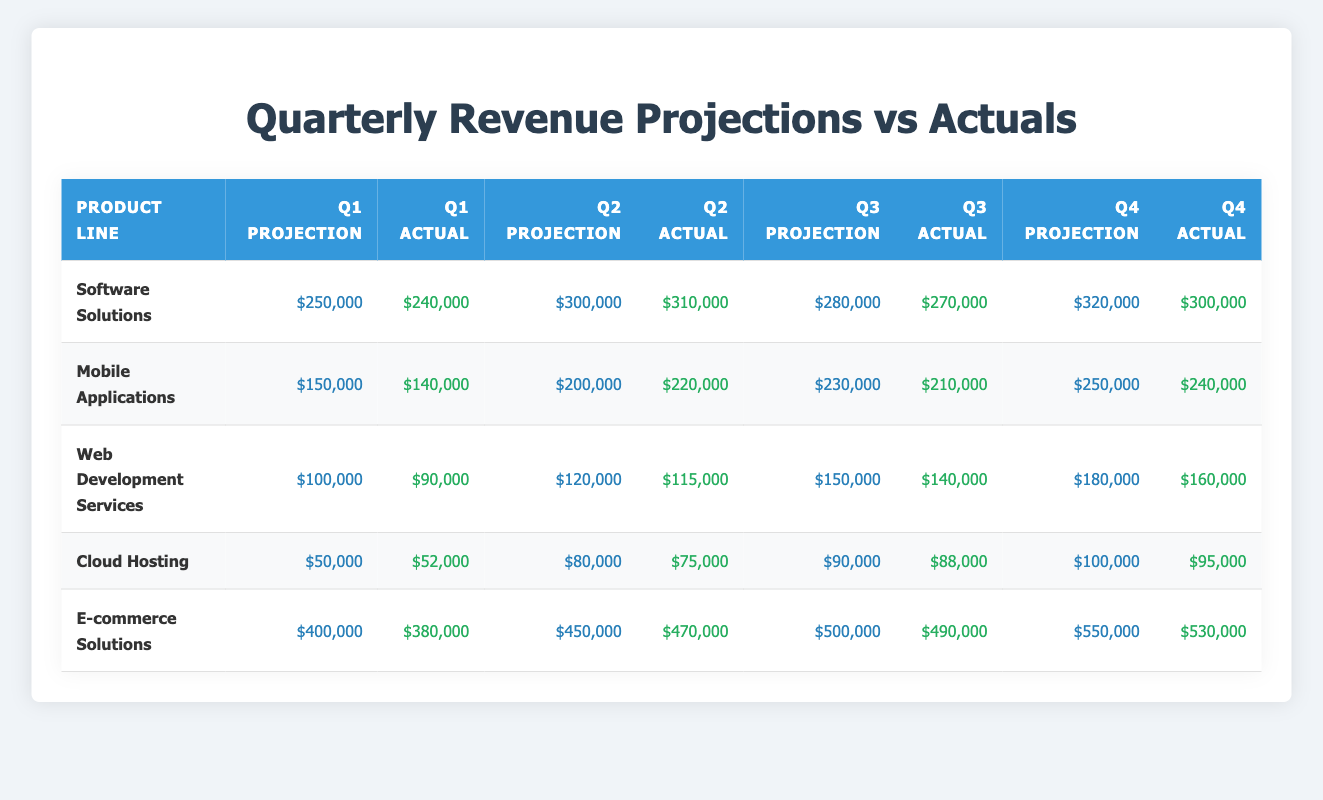What is the projected revenue for the Software Solutions product line in Q3? The table shows that the projection for the Software Solutions product line in Q3 is $280,000.
Answer: $280,000 What is the actual revenue for Mobile Applications in Q2? According to the table, the actual revenue for Mobile Applications in Q2 is $220,000.
Answer: $220,000 Is the actual revenue for Cloud Hosting in Q1 higher than its projection? The actual revenue for Cloud Hosting in Q1 is $52,000, while the projection was $50,000, so yes, it is higher.
Answer: Yes What was the total projected revenue for all product lines in Q4? The total projected revenue in Q4 is calculated by summing the projections: $320,000 (Software Solutions) + $250,000 (Mobile Applications) + $180,000 (Web Development Services) + $100,000 (Cloud Hosting) + $550,000 (E-commerce Solutions) = $1,400,000.
Answer: $1,400,000 What is the difference between Q3 actuals and projections for Web Development Services? The actual revenue for Q3 of Web Development Services is $140,000, and the projection is $150,000. The difference is $150,000 - $140,000 = $10,000.
Answer: $10,000 For which product line was the average of actual revenues (across all quarters) the highest? To find this, we calculate the average of actual revenues for each product: Software Solutions: (240,000 + 310,000 + 270,000 + 300,000) / 4 = 280,000; Mobile Applications: (140,000 + 220,000 + 210,000 + 240,000) / 4 = 202,500; Web Development Services: (90,000 + 115,000 + 140,000 + 160,000) / 4 = 126,250; Cloud Hosting: (52,000 + 75,000 + 88,000 + 95,000) / 4 = 77,500; E-commerce Solutions: (380,000 + 470,000 + 490,000 + 530,000) / 4 = 467,500. The highest average is for E-commerce Solutions.
Answer: E-commerce Solutions Which product line had the largest discrepancy between projection and actual revenue in Q2? For Q2, the discrepancies are as follows: Software Solutions: 300,000 - 310,000 = 10,000; Mobile Applications: 200,000 - 220,000 = 20,000; Web Development Services: 120,000 - 115,000 = 5,000; Cloud Hosting: 80,000 - 75,000 = 5,000; E-commerce Solutions: 450,000 - 470,000 = 20,000. The largest discrepancy is for Mobile Applications & E-commerce Solutions with $20,000.
Answer: Mobile Applications & E-commerce Solutions What is the total actual revenue for all product lines in Q1? The total actual revenue in Q1 is calculated by summing the actual revenues: $240,000 (Software Solutions) + $140,000 (Mobile Applications) + $90,000 (Web Development Services) + $52,000 (Cloud Hosting) + $380,000 (E-commerce Solutions) = $902,000.
Answer: $902,000 Which quarter saw the highest overall projected revenue across all product lines? To determine this, we sum the projections for each quarter: Q1: $250,000 + $150,000 + $100,000 + $50,000 + $400,000 = $950,000; Q2: $300,000 + $200,000 + $120,000 + $80,000 + $450,000 = $1,150,000; Q3: $280,000 + $230,000 + $150,000 + $90,000 + $500,000 = $1,250,000; Q4: $320,000 + $250,000 + $180,000 + $100,000 + $550,000 = $1,400,000. The highest overall projected revenue is in Q4.
Answer: Q4 What percentage of the actual revenue for E-commerce Solutions in Q4 was achieved compared to the projection? The actual revenue in Q4 for E-commerce Solutions is $530,000, and the projection is $550,000. To find the percentage achieved, we calculate ($530,000 / $550,000) * 100 = 96.36%.
Answer: 96.36% 